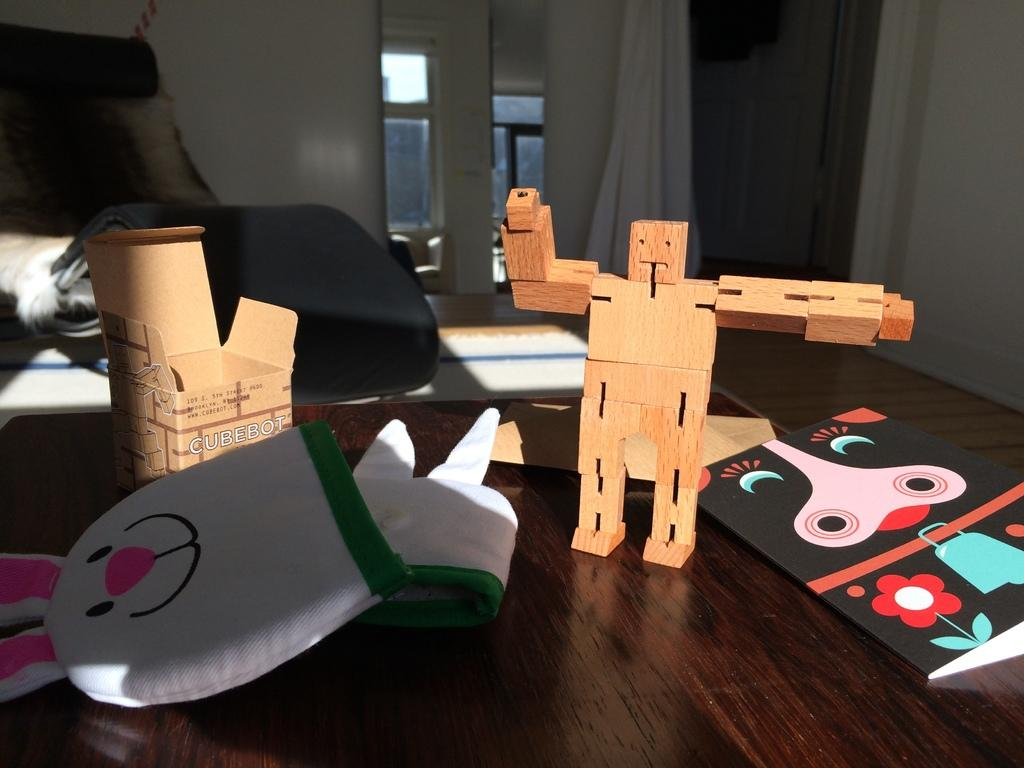Provide a one-sentence caption for the provided image. A box has "CUBEBOT" printed on the front. 